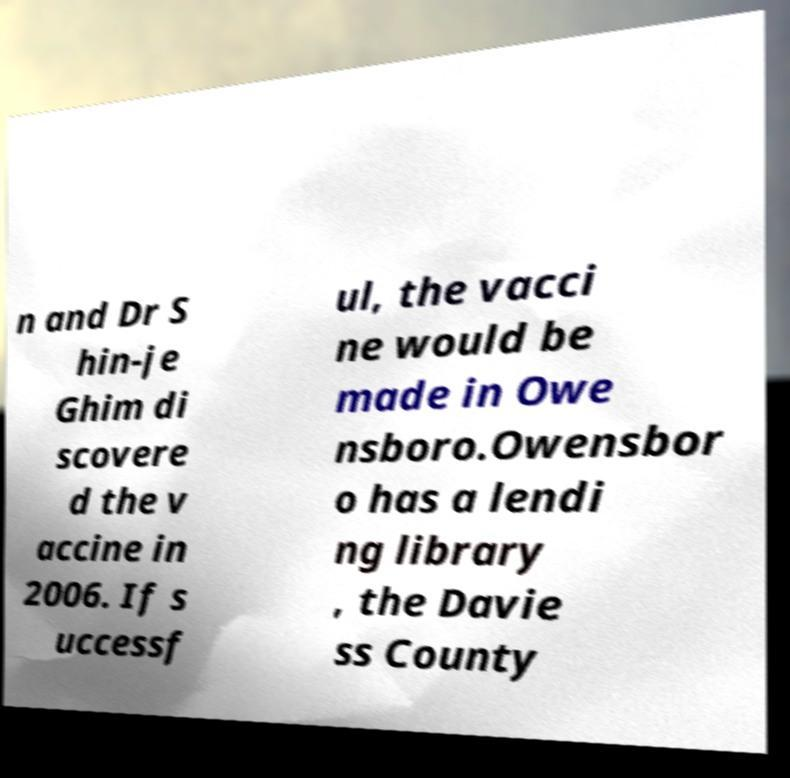Please identify and transcribe the text found in this image. n and Dr S hin-je Ghim di scovere d the v accine in 2006. If s uccessf ul, the vacci ne would be made in Owe nsboro.Owensbor o has a lendi ng library , the Davie ss County 